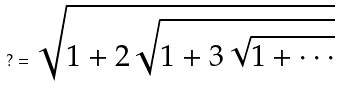<formula> <loc_0><loc_0><loc_500><loc_500>? = \sqrt { 1 + 2 \sqrt { 1 + 3 \sqrt { 1 + \cdot \cdot \cdot } } }</formula> 